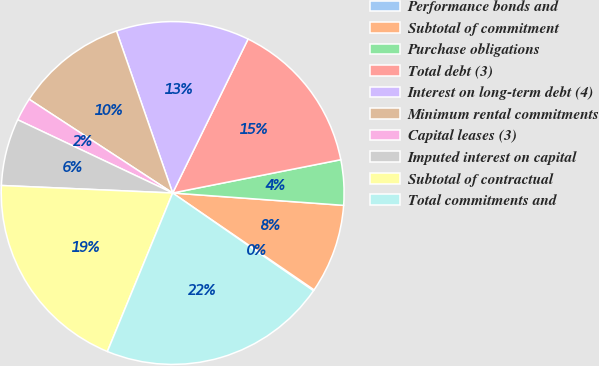Convert chart to OTSL. <chart><loc_0><loc_0><loc_500><loc_500><pie_chart><fcel>Performance bonds and<fcel>Subtotal of commitment<fcel>Purchase obligations<fcel>Total debt (3)<fcel>Interest on long-term debt (4)<fcel>Minimum rental commitments<fcel>Capital leases (3)<fcel>Imputed interest on capital<fcel>Subtotal of contractual<fcel>Total commitments and<nl><fcel>0.1%<fcel>8.41%<fcel>4.26%<fcel>14.64%<fcel>12.56%<fcel>10.48%<fcel>2.18%<fcel>6.33%<fcel>19.48%<fcel>21.56%<nl></chart> 